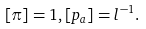<formula> <loc_0><loc_0><loc_500><loc_500>[ \pi ] = 1 , [ p _ { a } ] = l ^ { - 1 } .</formula> 